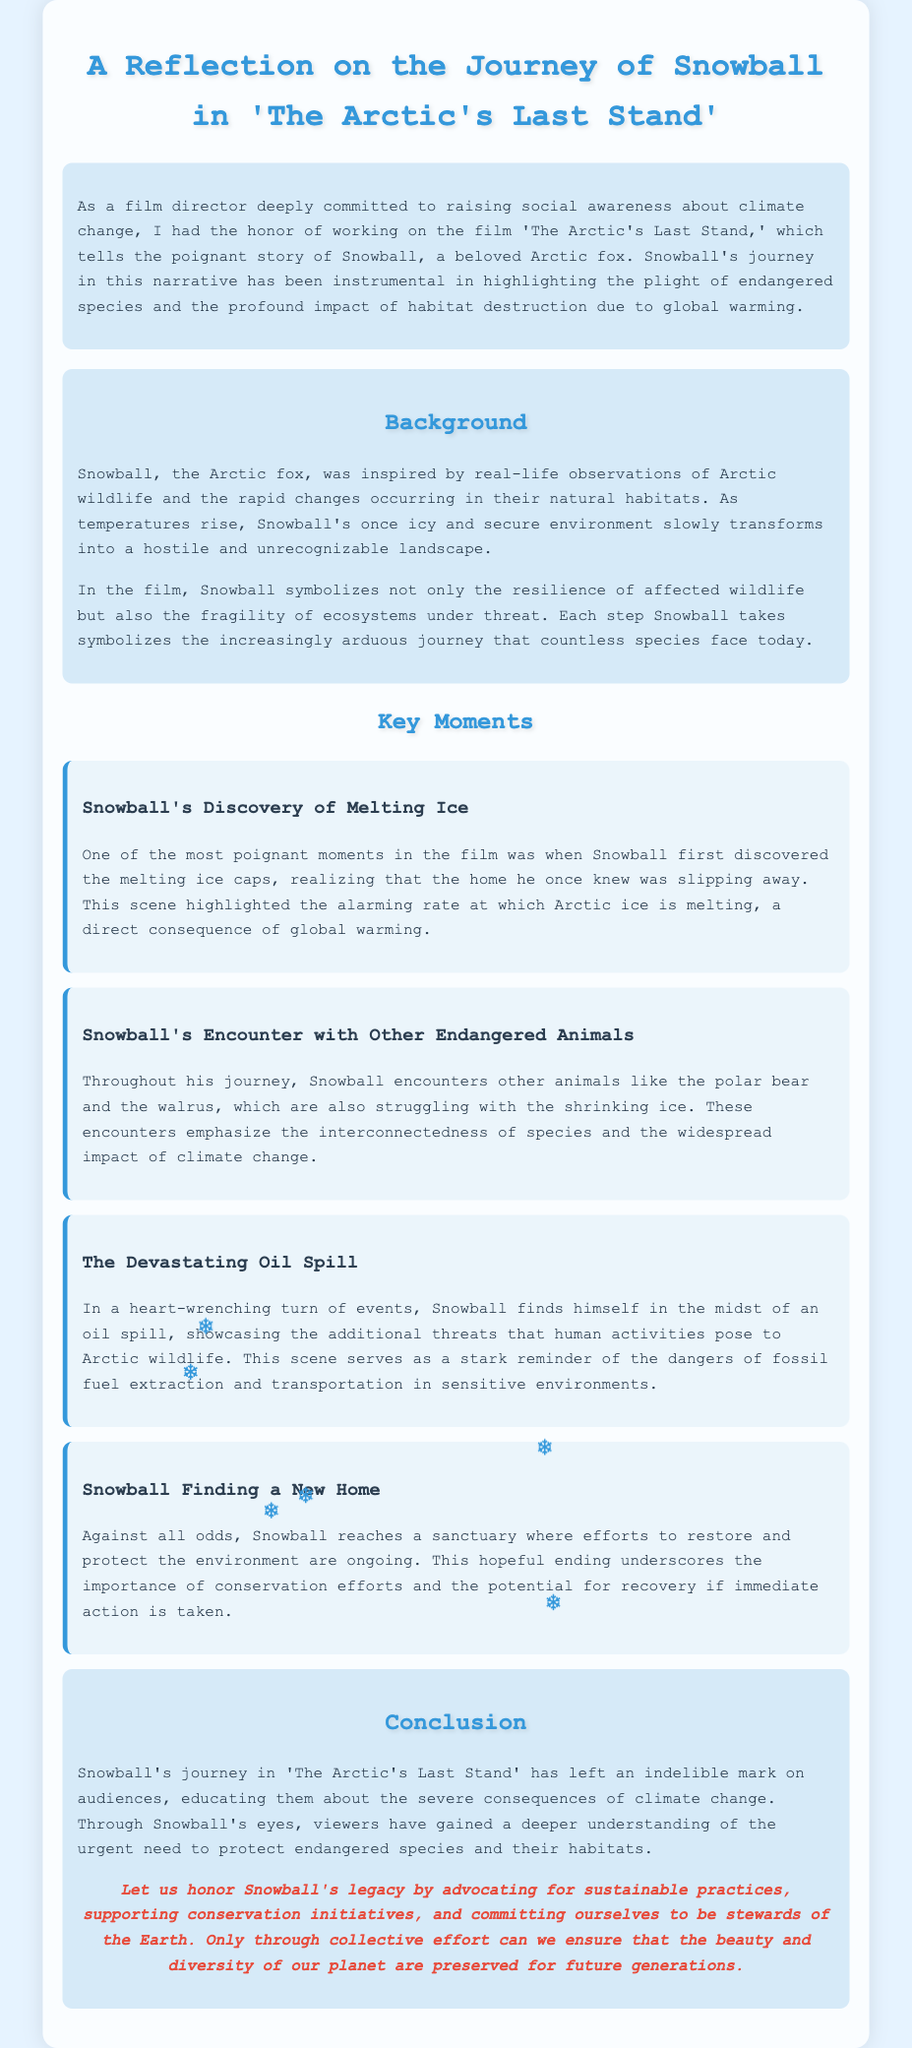What is the title of the film? The title of the film about Snowball is mentioned at the beginning of the document.
Answer: The Arctic's Last Stand Who is the main character of the film? The main character, highlighted throughout the eulogy, is an Arctic fox named Snowball.
Answer: Snowball What does Snowball symbolize in the film? The document states that Snowball symbolizes the resilience of wildlife and the fragility of ecosystems.
Answer: Resilience and fragility What is one major event Snowball encounters? The key moments section lists significant events where Snowball encounters various challenges, including a major environmental disaster.
Answer: The Devastating Oil Spill What is the conclusion's call to action? The conclusion emphasizes the importance of advocating for sustainable practices and supporting conservation.
Answer: Advocate for sustainable practices In which environment does Snowball initially live? The document describes Snowball's initial environment as an icy and secure setting before it becomes unrecognizable.
Answer: Icy and secure How does Snowball find hope in the story? The conclusion mentions a sanctuary where efforts for restoration and protection are ongoing, offering hope for recovery.
Answer: A sanctuary for restoration What theme does Snowball's journey primarily address? Throughout the text, it is clear that the character's journey addresses the consequences of climate change on wildlife and habitats.
Answer: Climate change consequences 